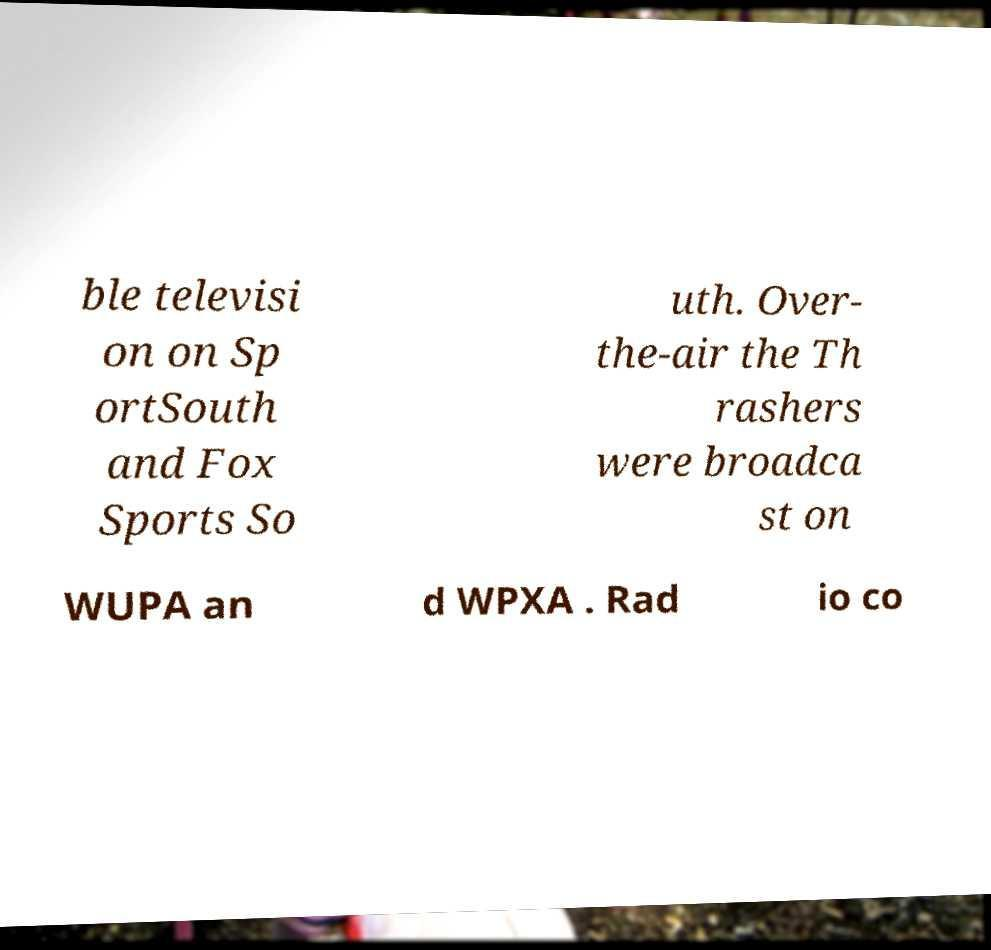There's text embedded in this image that I need extracted. Can you transcribe it verbatim? ble televisi on on Sp ortSouth and Fox Sports So uth. Over- the-air the Th rashers were broadca st on WUPA an d WPXA . Rad io co 